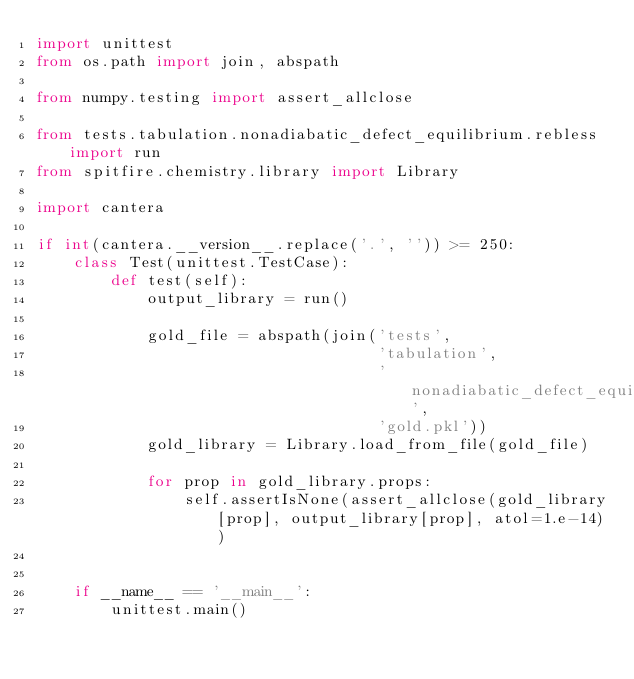<code> <loc_0><loc_0><loc_500><loc_500><_Python_>import unittest
from os.path import join, abspath

from numpy.testing import assert_allclose

from tests.tabulation.nonadiabatic_defect_equilibrium.rebless import run
from spitfire.chemistry.library import Library

import cantera

if int(cantera.__version__.replace('.', '')) >= 250:
    class Test(unittest.TestCase):
        def test(self):
            output_library = run()

            gold_file = abspath(join('tests',
                                     'tabulation',
                                     'nonadiabatic_defect_equilibrium',
                                     'gold.pkl'))
            gold_library = Library.load_from_file(gold_file)

            for prop in gold_library.props:
                self.assertIsNone(assert_allclose(gold_library[prop], output_library[prop], atol=1.e-14))


    if __name__ == '__main__':
        unittest.main()
</code> 